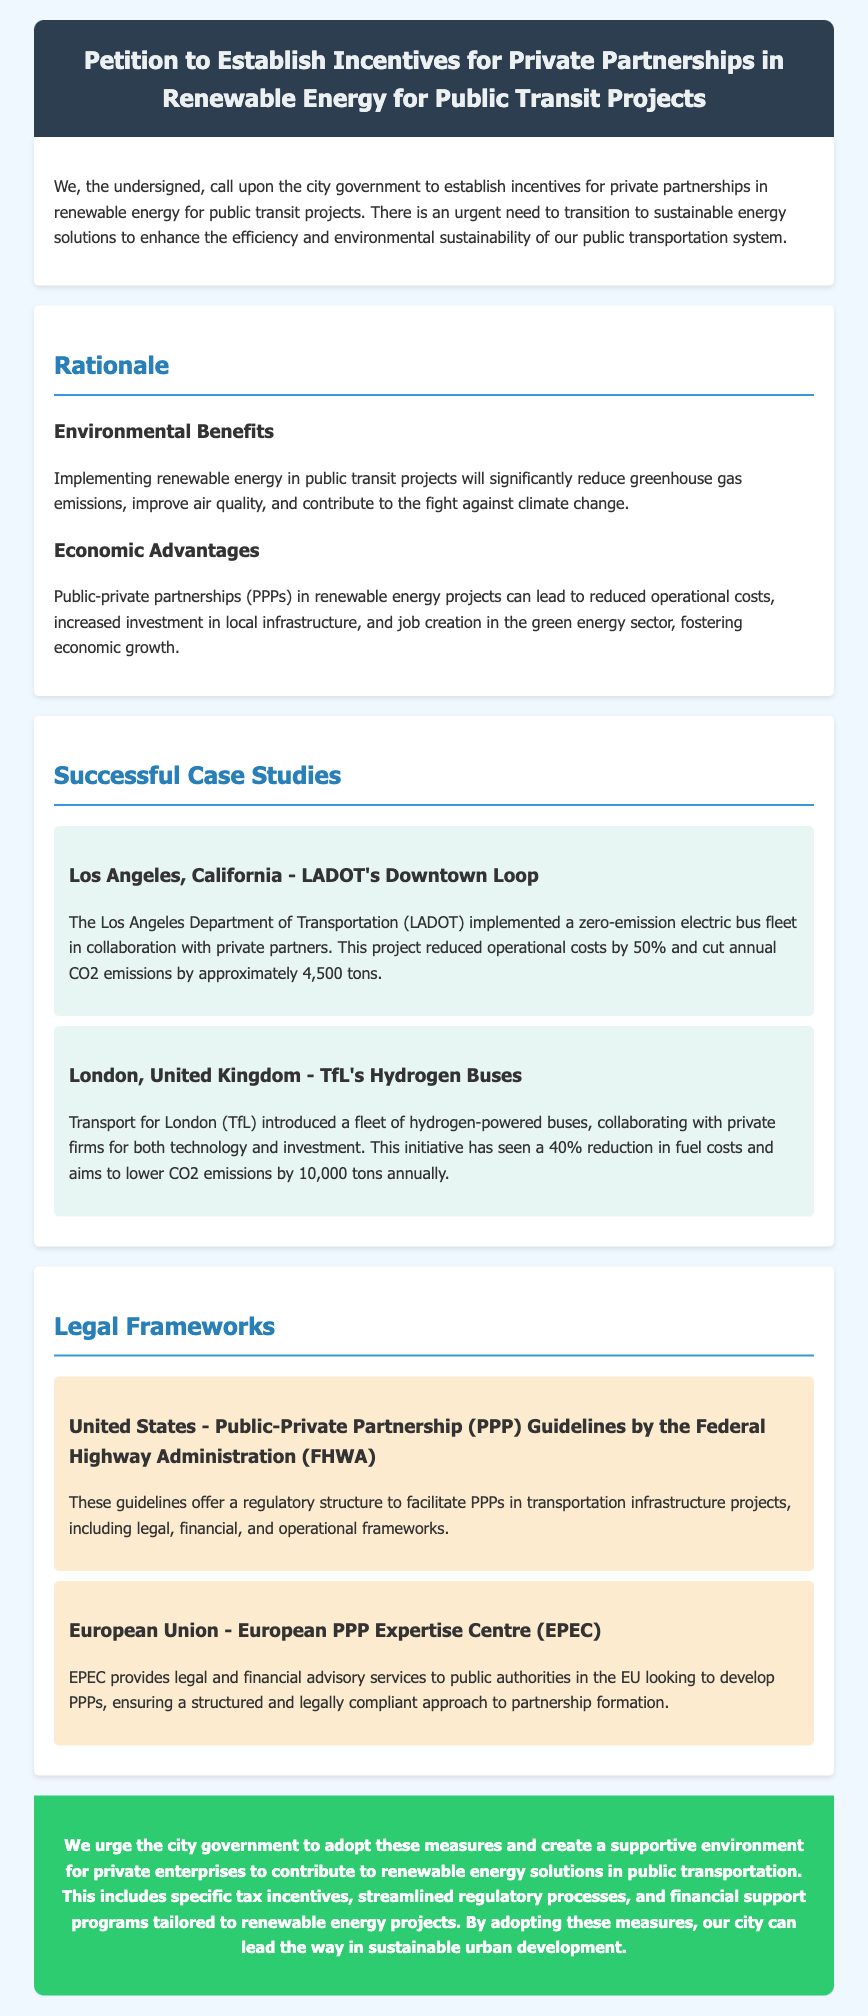What is the title of the petition? The title of the petition is featured prominently in the header section of the document, which states the purpose of the document.
Answer: Petition to Establish Incentives for Private Partnerships in Renewable Energy for Public Transit Projects What city is mentioned in the first case study? The first case study discusses a project implemented by the Los Angeles Department of Transportation, indicating that Los Angeles is the city in question.
Answer: Los Angeles What type of bus fleet did LADOT implement? The document specifies that LADOT implemented a zero-emission electric bus fleet, highlighting the type of technology used in the project.
Answer: zero-emission electric bus fleet What percentage reduction in operational costs was achieved by LADOT? The document notes that the LADOT project resulted in a 50% reduction in operational costs, providing a clear numerical figure related to the project's success.
Answer: 50% What is the aim of TfL's hydrogen buses project in terms of CO2 emissions? The text states that the TfL initiative aims to lower CO2 emissions by a specific quantity, emphasizing the environmental goals of the project.
Answer: 10,000 tons What does EPEC stand for? The acronym EPEC is mentioned in the legal frameworks section, and the full name is important for understanding the context of the European partnership mentioned.
Answer: European PPP Expertise Centre What two types of advantages are discussed in the petition's rationale? The rationale section outlines both environmental and economic advantages, addressing the impacts of renewable energy on multiple fronts.
Answer: Environmental, Economic 